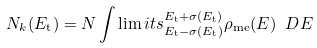<formula> <loc_0><loc_0><loc_500><loc_500>N _ { k } ( E _ { \text {t} } ) = N \int \lim i t s _ { E _ { \text {t} } - \sigma ( E _ { \text {t} } ) } ^ { E _ { \text {t} } + \sigma ( E _ { \text {t} } ) } \rho _ { \text {me} } ( E ) \ D E</formula> 